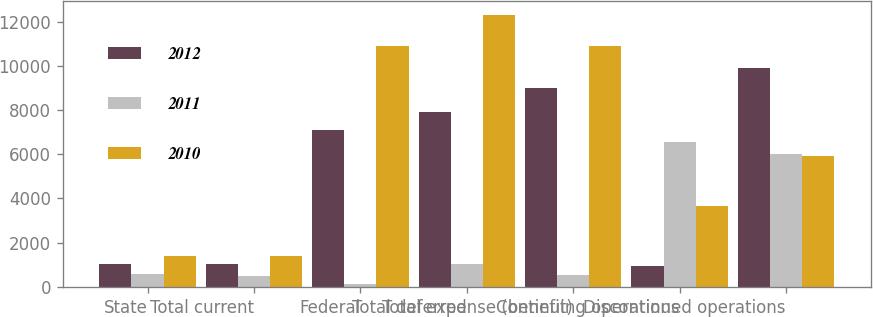Convert chart to OTSL. <chart><loc_0><loc_0><loc_500><loc_500><stacked_bar_chart><ecel><fcel>State<fcel>Total current<fcel>Federal<fcel>Total deferred<fcel>Total expense (benefit)<fcel>Continuing operations<fcel>Discontinued operations<nl><fcel>2012<fcel>1047<fcel>1047<fcel>7116<fcel>7928<fcel>8975<fcel>929<fcel>9904<nl><fcel>2011<fcel>604<fcel>495<fcel>143<fcel>1046<fcel>551<fcel>6541<fcel>5990<nl><fcel>2010<fcel>1395<fcel>1395<fcel>10912<fcel>12292<fcel>10897<fcel>3668.5<fcel>5942<nl></chart> 